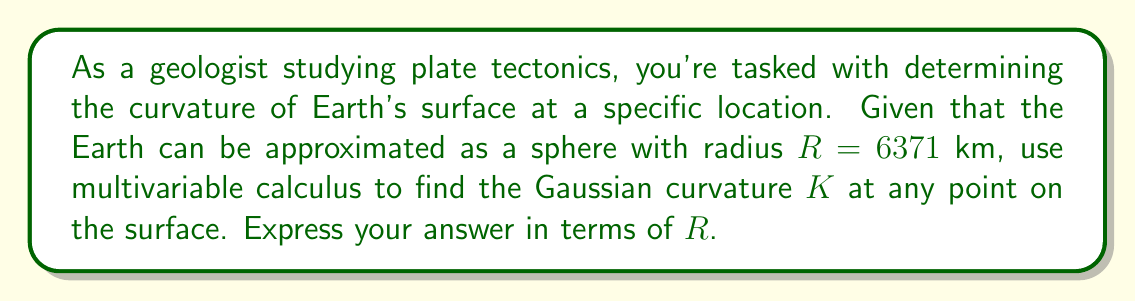Show me your answer to this math problem. To determine the Gaussian curvature of the Earth's surface, we'll follow these steps:

1) First, we need to parameterize the Earth's surface. Using spherical coordinates, we can represent a point on the surface as:

   $$\mathbf{r}(\theta, \phi) = (R\sin\theta\cos\phi, R\sin\theta\sin\phi, R\cos\theta)$$

   where $\theta$ is the polar angle and $\phi$ is the azimuthal angle.

2) Next, we calculate the partial derivatives:

   $$\mathbf{r}_\theta = (R\cos\theta\cos\phi, R\cos\theta\sin\phi, -R\sin\theta)$$
   $$\mathbf{r}_\phi = (-R\sin\theta\sin\phi, R\sin\theta\cos\phi, 0)$$

3) The first fundamental form coefficients are:

   $$E = \mathbf{r}_\theta \cdot \mathbf{r}_\theta = R^2$$
   $$F = \mathbf{r}_\theta \cdot \mathbf{r}_\phi = 0$$
   $$G = \mathbf{r}_\phi \cdot \mathbf{r}_\phi = R^2\sin^2\theta$$

4) The unit normal vector is:

   $$\mathbf{n} = \frac{\mathbf{r}_\theta \times \mathbf{r}_\phi}{|\mathbf{r}_\theta \times \mathbf{r}_\phi|} = (\sin\theta\cos\phi, \sin\theta\sin\phi, \cos\theta)$$

5) The second partial derivatives are:

   $$\mathbf{r}_{\theta\theta} = (-R\sin\theta\cos\phi, -R\sin\theta\sin\phi, -R\cos\theta)$$
   $$\mathbf{r}_{\theta\phi} = (-R\cos\theta\sin\phi, R\cos\theta\cos\phi, 0)$$
   $$\mathbf{r}_{\phi\phi} = (-R\sin\theta\cos\phi, -R\sin\theta\sin\phi, 0)$$

6) The second fundamental form coefficients are:

   $$L = \mathbf{r}_{\theta\theta} \cdot \mathbf{n} = -R$$
   $$M = \mathbf{r}_{\theta\phi} \cdot \mathbf{n} = 0$$
   $$N = \mathbf{r}_{\phi\phi} \cdot \mathbf{n} = -R\sin^2\theta$$

7) The Gaussian curvature is given by:

   $$K = \frac{LN - M^2}{EG - F^2}$$

8) Substituting the values:

   $$K = \frac{(-R)(-R\sin^2\theta) - 0^2}{R^2(R^2\sin^2\theta) - 0^2} = \frac{R^2\sin^2\theta}{R^4\sin^2\theta} = \frac{1}{R^2}$$

Therefore, the Gaussian curvature of the Earth's surface at any point is $\frac{1}{R^2}$.
Answer: $K = \frac{1}{R^2}$ 